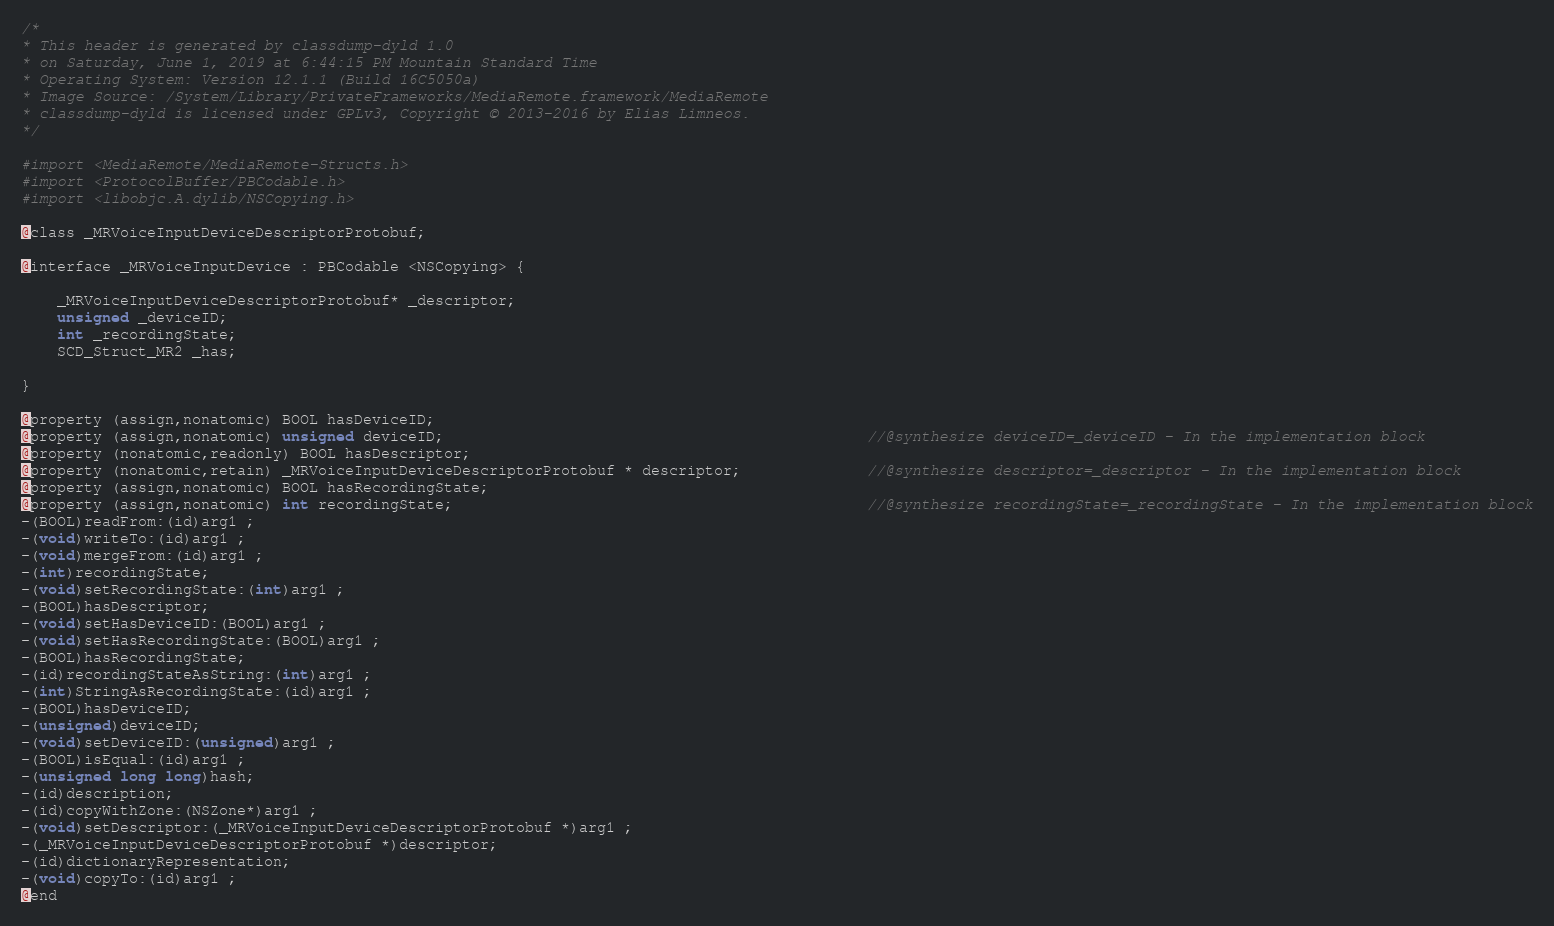<code> <loc_0><loc_0><loc_500><loc_500><_C_>/*
* This header is generated by classdump-dyld 1.0
* on Saturday, June 1, 2019 at 6:44:15 PM Mountain Standard Time
* Operating System: Version 12.1.1 (Build 16C5050a)
* Image Source: /System/Library/PrivateFrameworks/MediaRemote.framework/MediaRemote
* classdump-dyld is licensed under GPLv3, Copyright © 2013-2016 by Elias Limneos.
*/

#import <MediaRemote/MediaRemote-Structs.h>
#import <ProtocolBuffer/PBCodable.h>
#import <libobjc.A.dylib/NSCopying.h>

@class _MRVoiceInputDeviceDescriptorProtobuf;

@interface _MRVoiceInputDevice : PBCodable <NSCopying> {

	_MRVoiceInputDeviceDescriptorProtobuf* _descriptor;
	unsigned _deviceID;
	int _recordingState;
	SCD_Struct_MR2 _has;

}

@property (assign,nonatomic) BOOL hasDeviceID; 
@property (assign,nonatomic) unsigned deviceID;                                               //@synthesize deviceID=_deviceID - In the implementation block
@property (nonatomic,readonly) BOOL hasDescriptor; 
@property (nonatomic,retain) _MRVoiceInputDeviceDescriptorProtobuf * descriptor;              //@synthesize descriptor=_descriptor - In the implementation block
@property (assign,nonatomic) BOOL hasRecordingState; 
@property (assign,nonatomic) int recordingState;                                              //@synthesize recordingState=_recordingState - In the implementation block
-(BOOL)readFrom:(id)arg1 ;
-(void)writeTo:(id)arg1 ;
-(void)mergeFrom:(id)arg1 ;
-(int)recordingState;
-(void)setRecordingState:(int)arg1 ;
-(BOOL)hasDescriptor;
-(void)setHasDeviceID:(BOOL)arg1 ;
-(void)setHasRecordingState:(BOOL)arg1 ;
-(BOOL)hasRecordingState;
-(id)recordingStateAsString:(int)arg1 ;
-(int)StringAsRecordingState:(id)arg1 ;
-(BOOL)hasDeviceID;
-(unsigned)deviceID;
-(void)setDeviceID:(unsigned)arg1 ;
-(BOOL)isEqual:(id)arg1 ;
-(unsigned long long)hash;
-(id)description;
-(id)copyWithZone:(NSZone*)arg1 ;
-(void)setDescriptor:(_MRVoiceInputDeviceDescriptorProtobuf *)arg1 ;
-(_MRVoiceInputDeviceDescriptorProtobuf *)descriptor;
-(id)dictionaryRepresentation;
-(void)copyTo:(id)arg1 ;
@end

</code> 